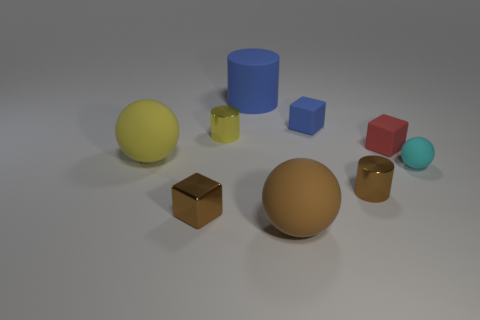Subtract all cylinders. How many objects are left? 6 Subtract all large matte objects. Subtract all yellow spheres. How many objects are left? 5 Add 2 small yellow shiny objects. How many small yellow shiny objects are left? 3 Add 5 small brown metal cylinders. How many small brown metal cylinders exist? 6 Subtract 0 cyan blocks. How many objects are left? 9 